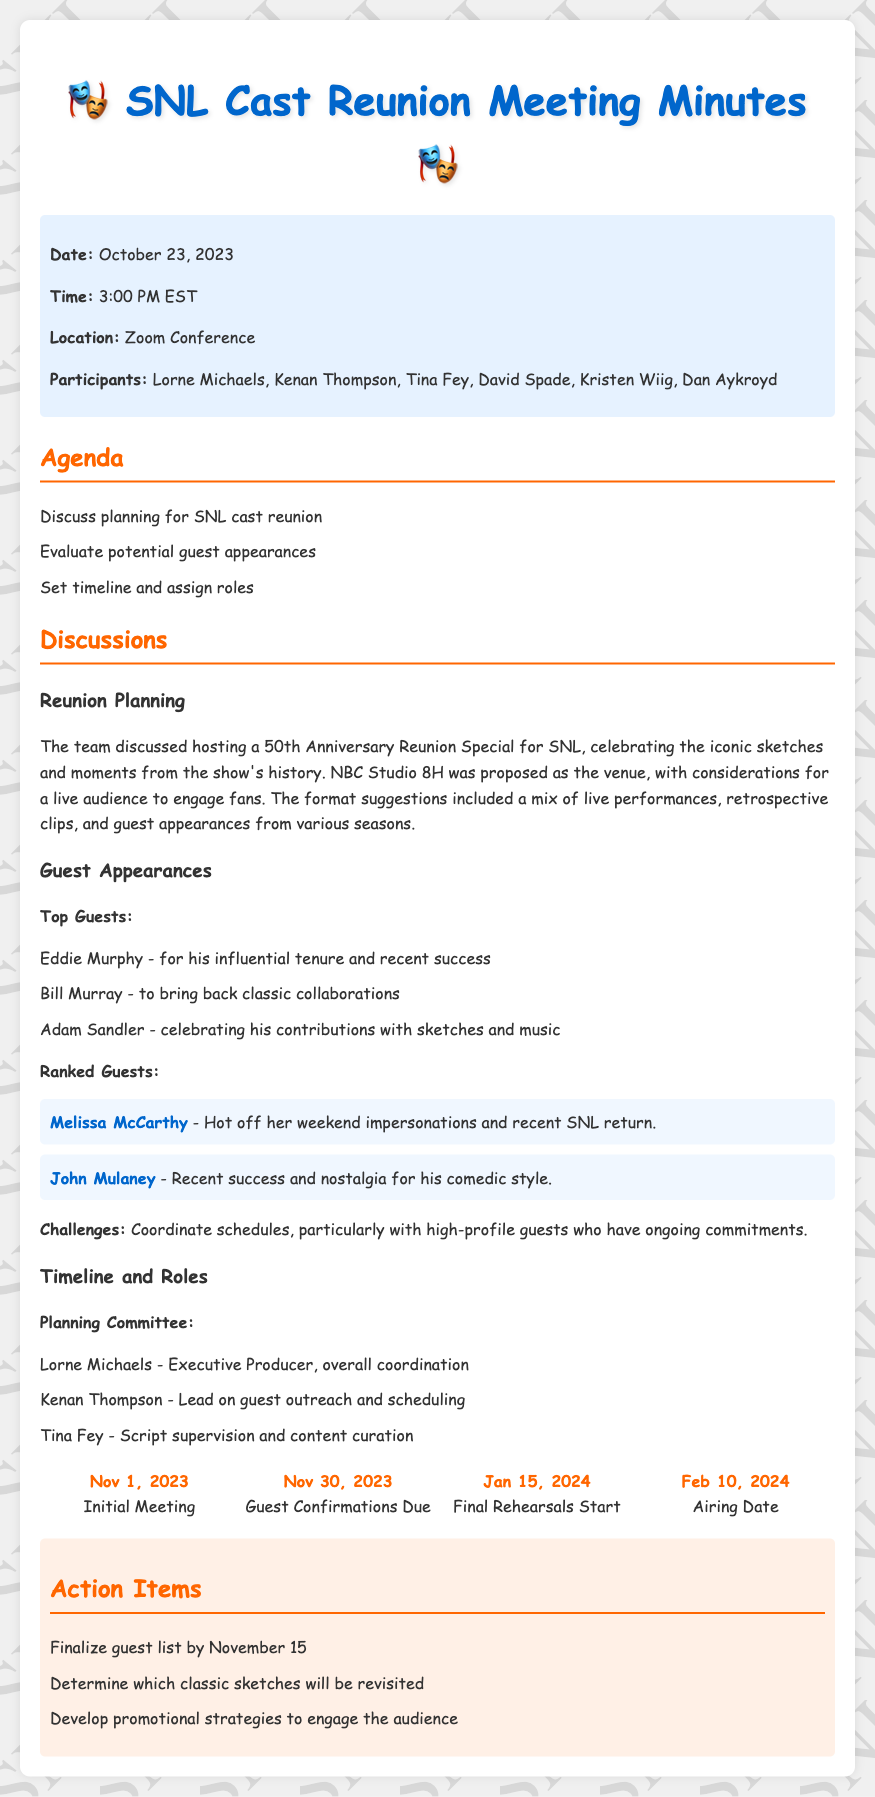What is the date of the meeting? The date of the meeting is stated in the information section of the document.
Answer: October 23, 2023 Who is the Executive Producer? The document specifies the individual's role in the planning committee section.
Answer: Lorne Michaels What is the venue proposed for the reunion? The venue is mentioned in the discussions about the reunion planning.
Answer: NBC Studio 8H Who are the top three potential guests? The top guests are listed in the guest appearances section of the document.
Answer: Eddie Murphy, Bill Murray, Adam Sandler What is the due date for guest confirmations? The timeline section includes dates relevant to the planning process.
Answer: November 30, 2023 What role does Kenan Thompson have? Kenan Thompson's responsibilities are outlined in the planning committee section of the document.
Answer: Lead on guest outreach and scheduling What are the action items to be completed? The action items are listed towards the end of the document as tasks to be done.
Answer: Finalize guest list, Determine classic sketches, Develop promotional strategies What is the air date for the reunion special? The air date is part of the timeline provided in the document.
Answer: February 10, 2024 